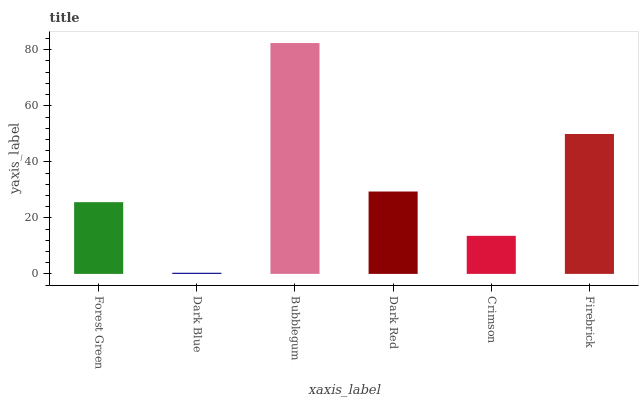Is Dark Blue the minimum?
Answer yes or no. Yes. Is Bubblegum the maximum?
Answer yes or no. Yes. Is Bubblegum the minimum?
Answer yes or no. No. Is Dark Blue the maximum?
Answer yes or no. No. Is Bubblegum greater than Dark Blue?
Answer yes or no. Yes. Is Dark Blue less than Bubblegum?
Answer yes or no. Yes. Is Dark Blue greater than Bubblegum?
Answer yes or no. No. Is Bubblegum less than Dark Blue?
Answer yes or no. No. Is Dark Red the high median?
Answer yes or no. Yes. Is Forest Green the low median?
Answer yes or no. Yes. Is Firebrick the high median?
Answer yes or no. No. Is Crimson the low median?
Answer yes or no. No. 